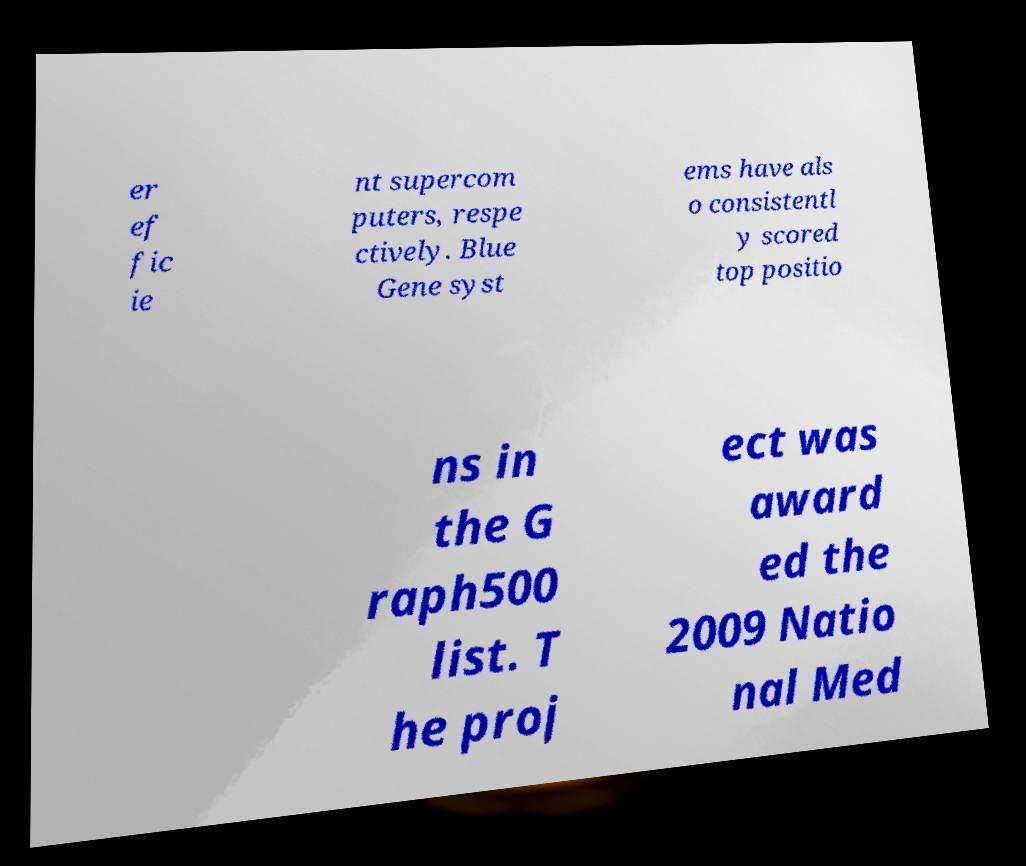I need the written content from this picture converted into text. Can you do that? er ef fic ie nt supercom puters, respe ctively. Blue Gene syst ems have als o consistentl y scored top positio ns in the G raph500 list. T he proj ect was award ed the 2009 Natio nal Med 